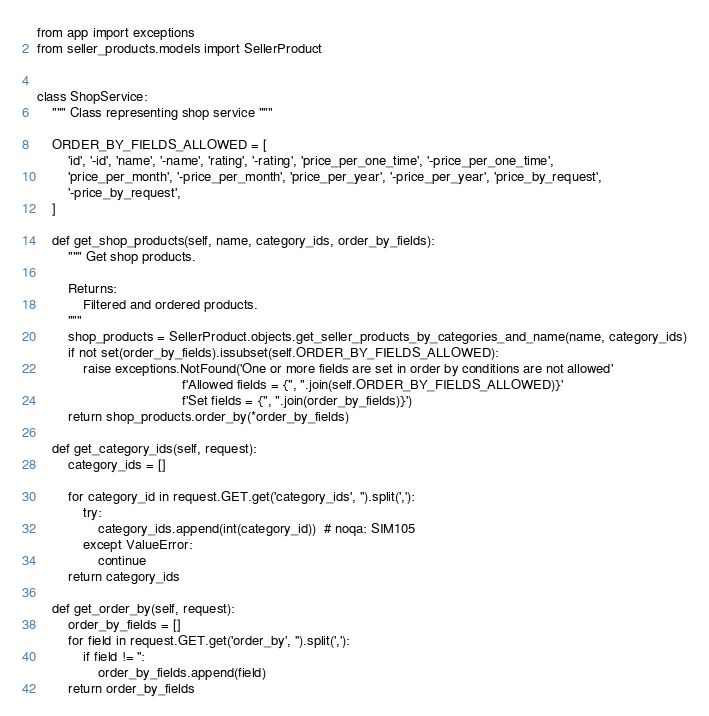<code> <loc_0><loc_0><loc_500><loc_500><_Python_>from app import exceptions
from seller_products.models import SellerProduct


class ShopService:
    """ Class representing shop service """

    ORDER_BY_FIELDS_ALLOWED = [
        'id', '-id', 'name', '-name', 'rating', '-rating', 'price_per_one_time', '-price_per_one_time',
        'price_per_month', '-price_per_month', 'price_per_year', '-price_per_year', 'price_by_request',
        '-price_by_request',
    ]

    def get_shop_products(self, name, category_ids, order_by_fields):
        """ Get shop products.

        Returns:
            Filtered and ordered products.
        """
        shop_products = SellerProduct.objects.get_seller_products_by_categories_and_name(name, category_ids)
        if not set(order_by_fields).issubset(self.ORDER_BY_FIELDS_ALLOWED):
            raise exceptions.NotFound('One or more fields are set in order by conditions are not allowed'
                                      f'Allowed fields = {", ".join(self.ORDER_BY_FIELDS_ALLOWED)}'
                                      f'Set fields = {", ".join(order_by_fields)}')
        return shop_products.order_by(*order_by_fields)

    def get_category_ids(self, request):
        category_ids = []

        for category_id in request.GET.get('category_ids', '').split(','):
            try:
                category_ids.append(int(category_id))  # noqa: SIM105
            except ValueError:
                continue
        return category_ids

    def get_order_by(self, request):
        order_by_fields = []
        for field in request.GET.get('order_by', '').split(','):
            if field != '':
                order_by_fields.append(field)
        return order_by_fields
</code> 